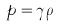<formula> <loc_0><loc_0><loc_500><loc_500>p = \gamma \rho</formula> 